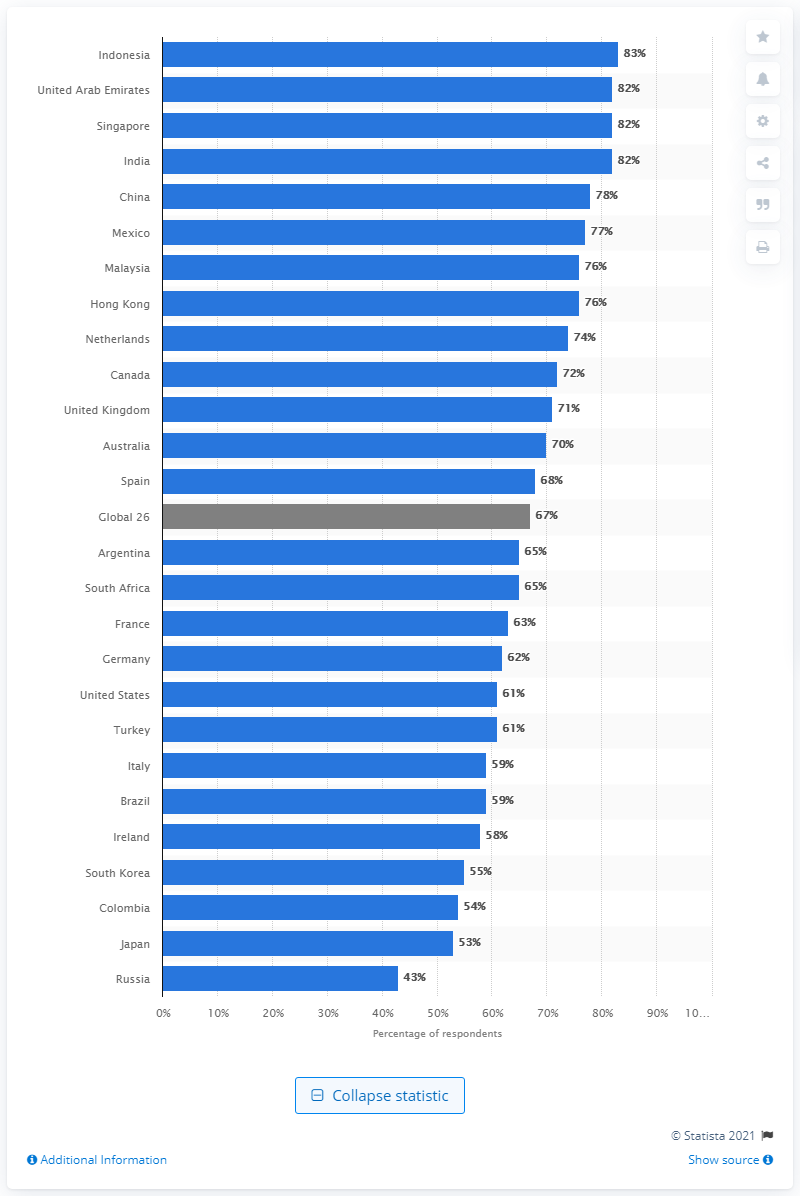List a handful of essential elements in this visual. Russia was the only country with a high level of distrust. 